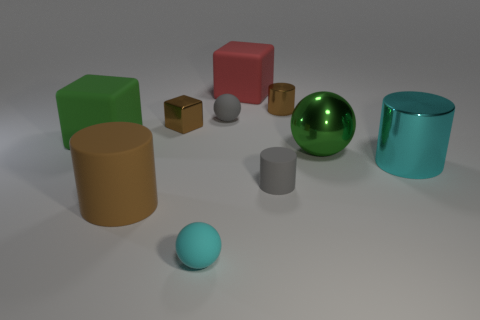Subtract 1 cylinders. How many cylinders are left? 3 Subtract all gray cylinders. How many cylinders are left? 3 Subtract all green cylinders. Subtract all gray spheres. How many cylinders are left? 4 Subtract all balls. How many objects are left? 7 Add 3 small brown metal cylinders. How many small brown metal cylinders exist? 4 Subtract 0 red cylinders. How many objects are left? 10 Subtract all large red matte things. Subtract all large brown cylinders. How many objects are left? 8 Add 1 tiny rubber cylinders. How many tiny rubber cylinders are left? 2 